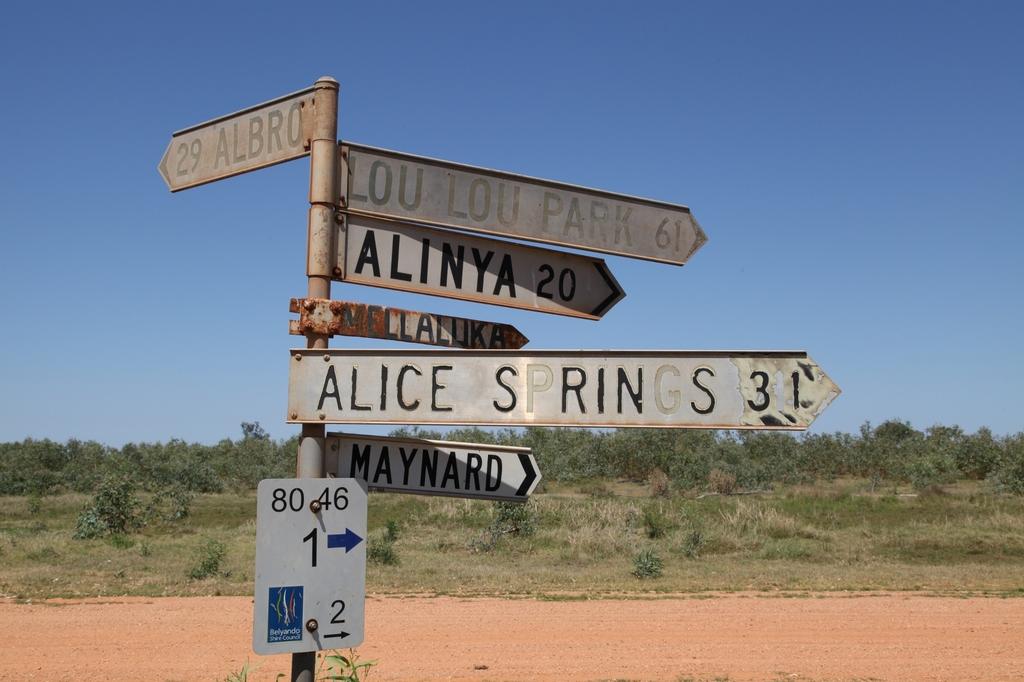How far is albro?
Offer a very short reply. 29. 